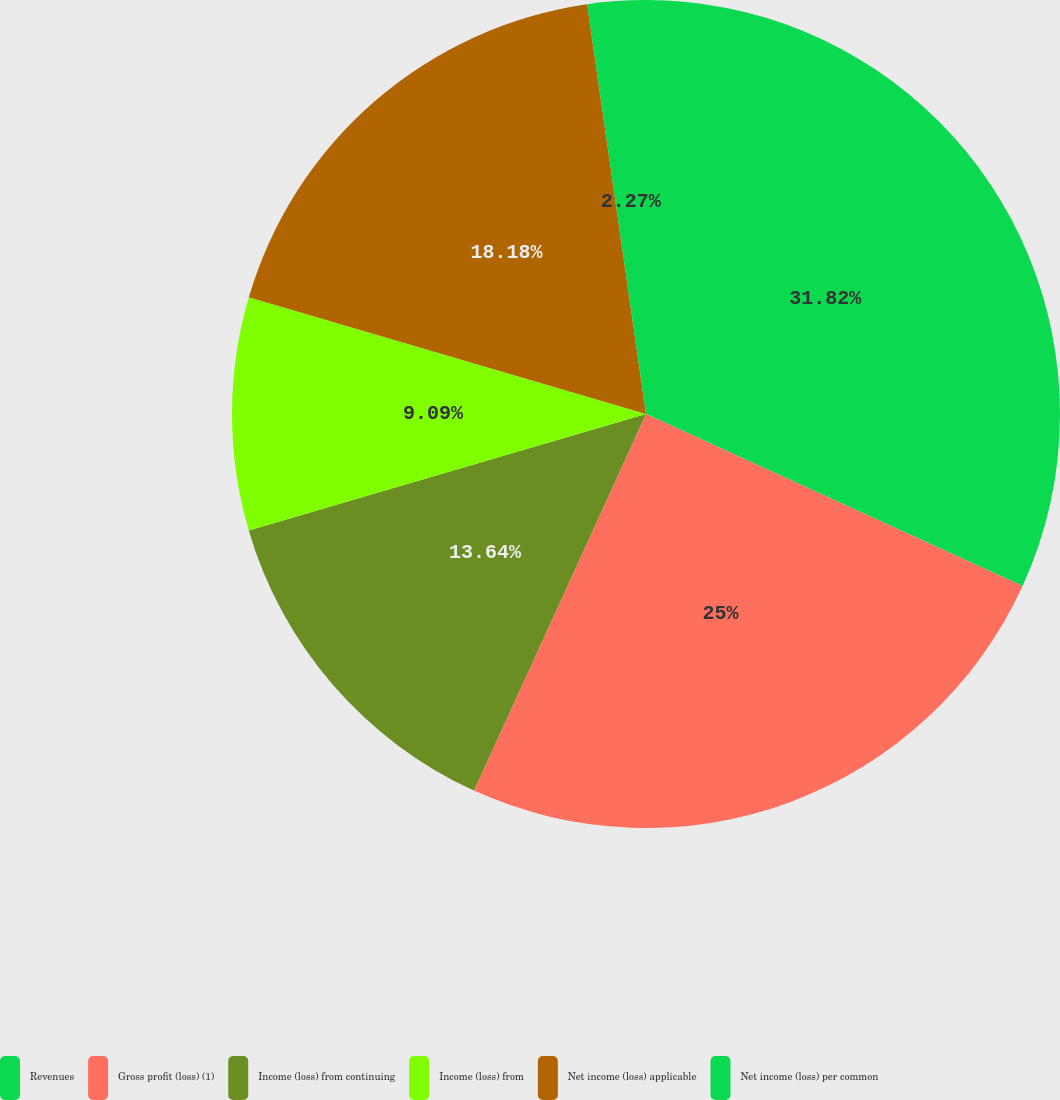Convert chart. <chart><loc_0><loc_0><loc_500><loc_500><pie_chart><fcel>Revenues<fcel>Gross profit (loss) (1)<fcel>Income (loss) from continuing<fcel>Income (loss) from<fcel>Net income (loss) applicable<fcel>Net income (loss) per common<nl><fcel>31.82%<fcel>25.0%<fcel>13.64%<fcel>9.09%<fcel>18.18%<fcel>2.27%<nl></chart> 